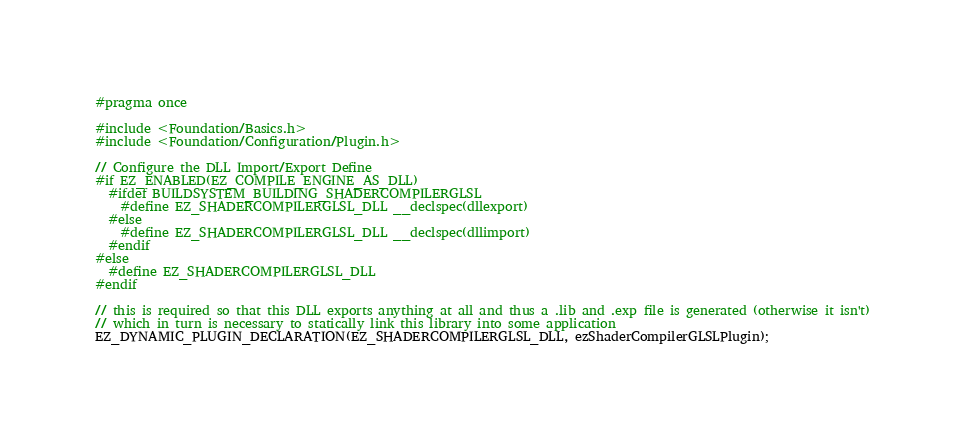<code> <loc_0><loc_0><loc_500><loc_500><_C_>#pragma once

#include <Foundation/Basics.h>
#include <Foundation/Configuration/Plugin.h>

// Configure the DLL Import/Export Define
#if EZ_ENABLED(EZ_COMPILE_ENGINE_AS_DLL)
  #ifdef BUILDSYSTEM_BUILDING_SHADERCOMPILERGLSL
    #define EZ_SHADERCOMPILERGLSL_DLL __declspec(dllexport)
  #else
    #define EZ_SHADERCOMPILERGLSL_DLL __declspec(dllimport)
  #endif
#else
  #define EZ_SHADERCOMPILERGLSL_DLL
#endif

// this is required so that this DLL exports anything at all and thus a .lib and .exp file is generated (otherwise it isn't)
// which in turn is necessary to statically link this library into some application
EZ_DYNAMIC_PLUGIN_DECLARATION(EZ_SHADERCOMPILERGLSL_DLL, ezShaderCompilerGLSLPlugin);</code> 